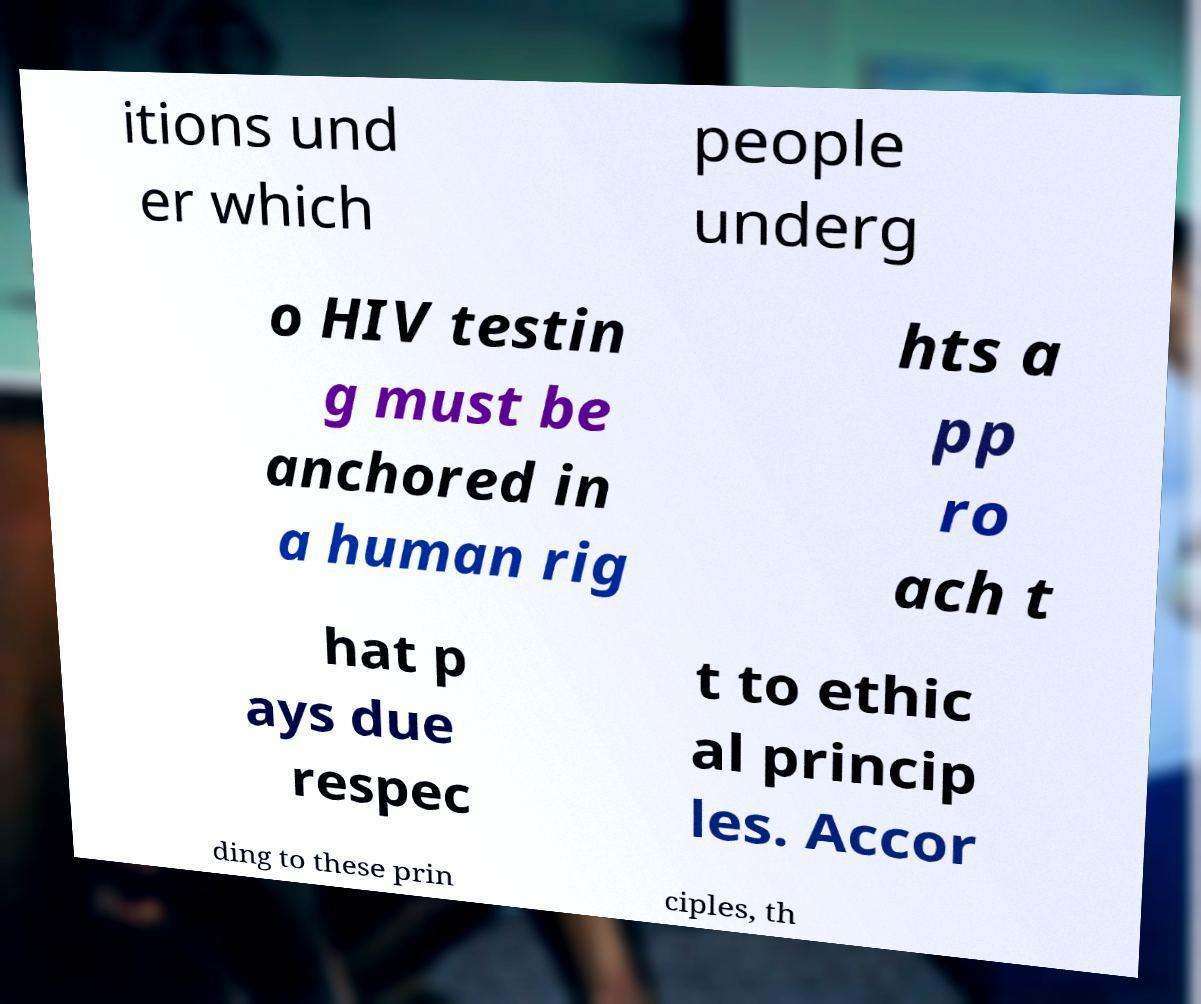There's text embedded in this image that I need extracted. Can you transcribe it verbatim? itions und er which people underg o HIV testin g must be anchored in a human rig hts a pp ro ach t hat p ays due respec t to ethic al princip les. Accor ding to these prin ciples, th 